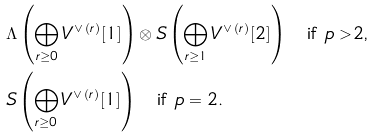<formula> <loc_0><loc_0><loc_500><loc_500>& \Lambda \left ( \bigoplus _ { r \geq 0 } V ^ { \vee \, ( r ) } [ 1 ] \right ) \otimes S \left ( \bigoplus _ { r \geq 1 } V ^ { \vee \, ( r ) } [ 2 ] \right ) \quad \text {if $p>2$,} \\ & S \left ( \bigoplus _ { r \geq 0 } V ^ { \vee \, ( r ) } [ 1 ] \right ) \quad \text {if $p=2$.}</formula> 